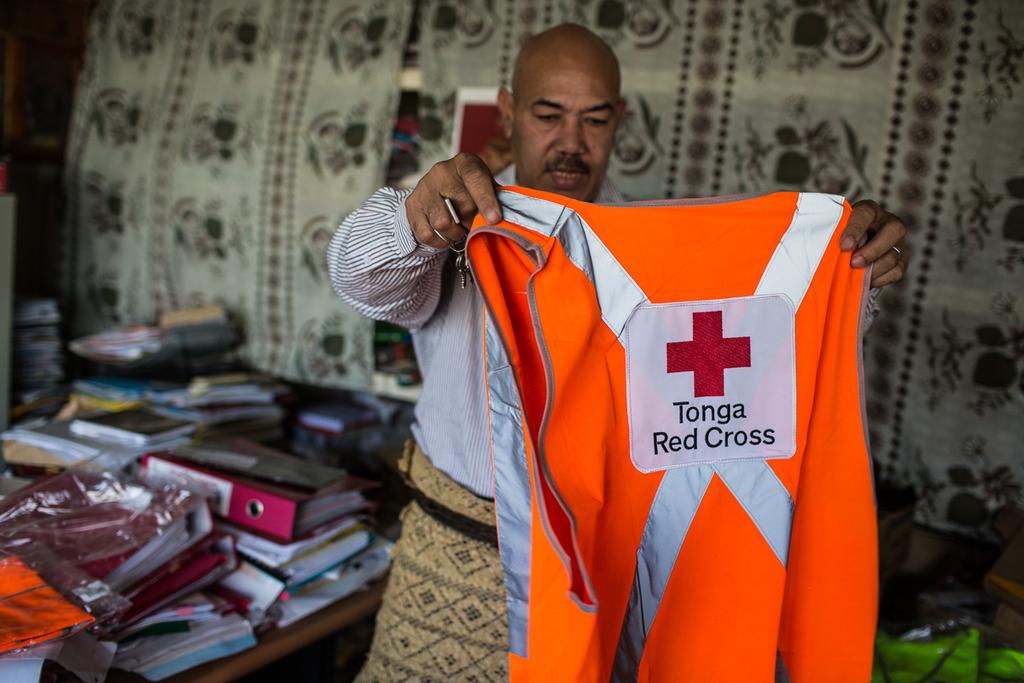Is that a red cross vest?
Your answer should be very brief. Yes. 